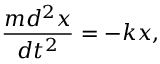<formula> <loc_0><loc_0><loc_500><loc_500>\frac { m d ^ { 2 } x } { d t ^ { 2 } } = - k x ,</formula> 